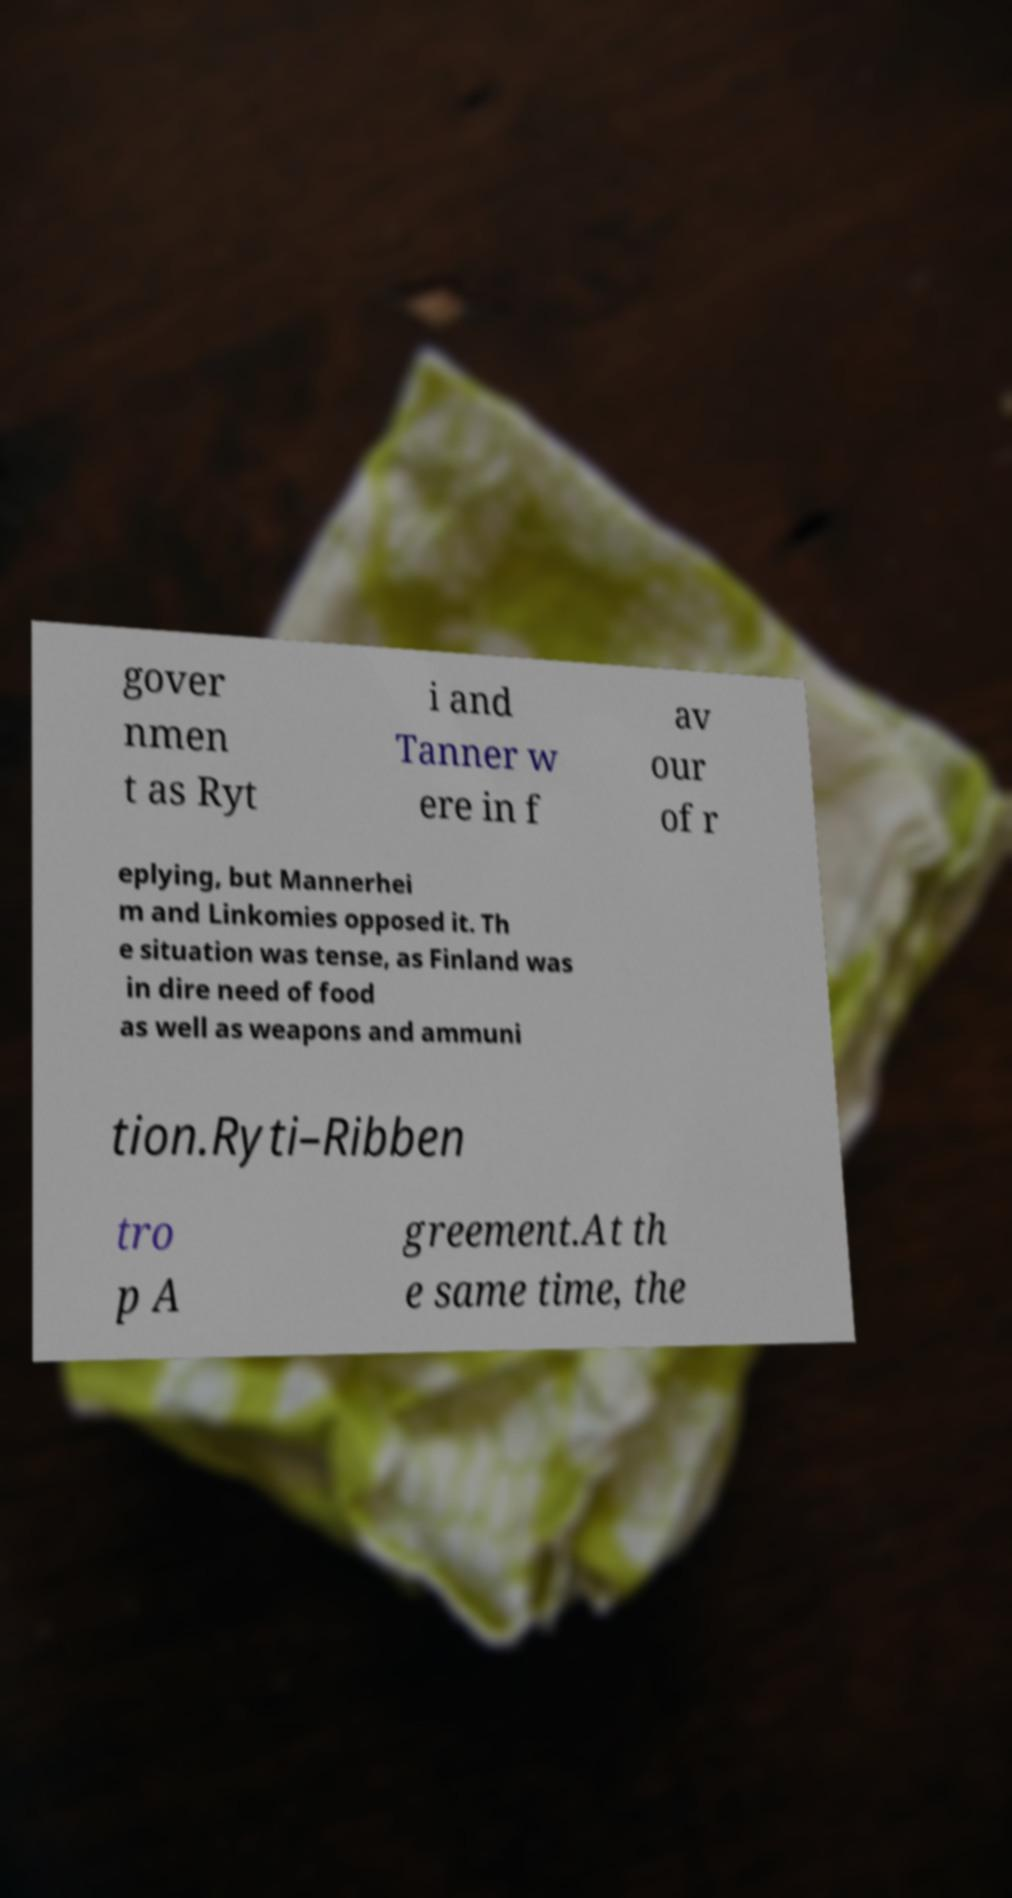What messages or text are displayed in this image? I need them in a readable, typed format. gover nmen t as Ryt i and Tanner w ere in f av our of r eplying, but Mannerhei m and Linkomies opposed it. Th e situation was tense, as Finland was in dire need of food as well as weapons and ammuni tion.Ryti–Ribben tro p A greement.At th e same time, the 